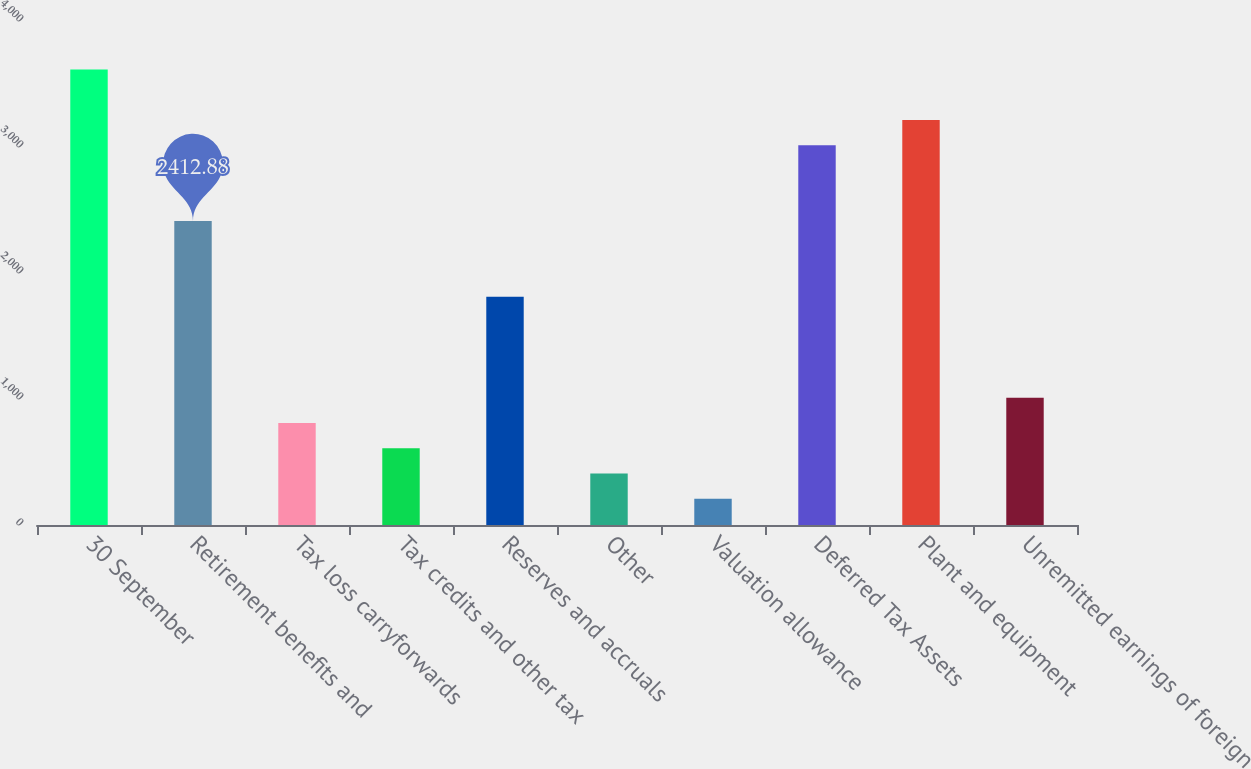Convert chart. <chart><loc_0><loc_0><loc_500><loc_500><bar_chart><fcel>30 September<fcel>Retirement benefits and<fcel>Tax loss carryforwards<fcel>Tax credits and other tax<fcel>Reserves and accruals<fcel>Other<fcel>Valuation allowance<fcel>Deferred Tax Assets<fcel>Plant and equipment<fcel>Unremitted earnings of foreign<nl><fcel>3615.52<fcel>2412.88<fcel>809.36<fcel>608.92<fcel>1811.56<fcel>408.48<fcel>208.04<fcel>3014.2<fcel>3214.64<fcel>1009.8<nl></chart> 